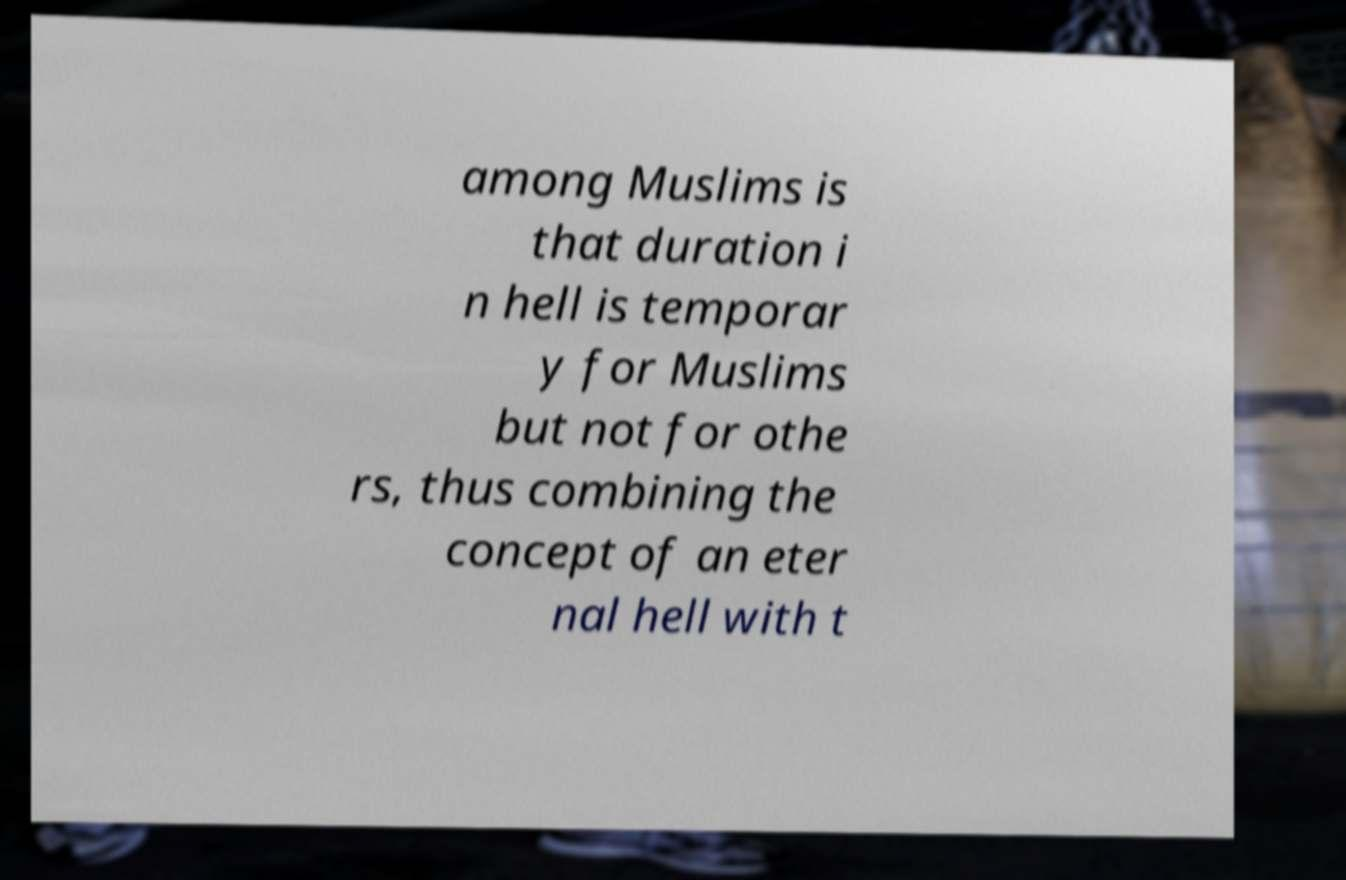Please identify and transcribe the text found in this image. among Muslims is that duration i n hell is temporar y for Muslims but not for othe rs, thus combining the concept of an eter nal hell with t 